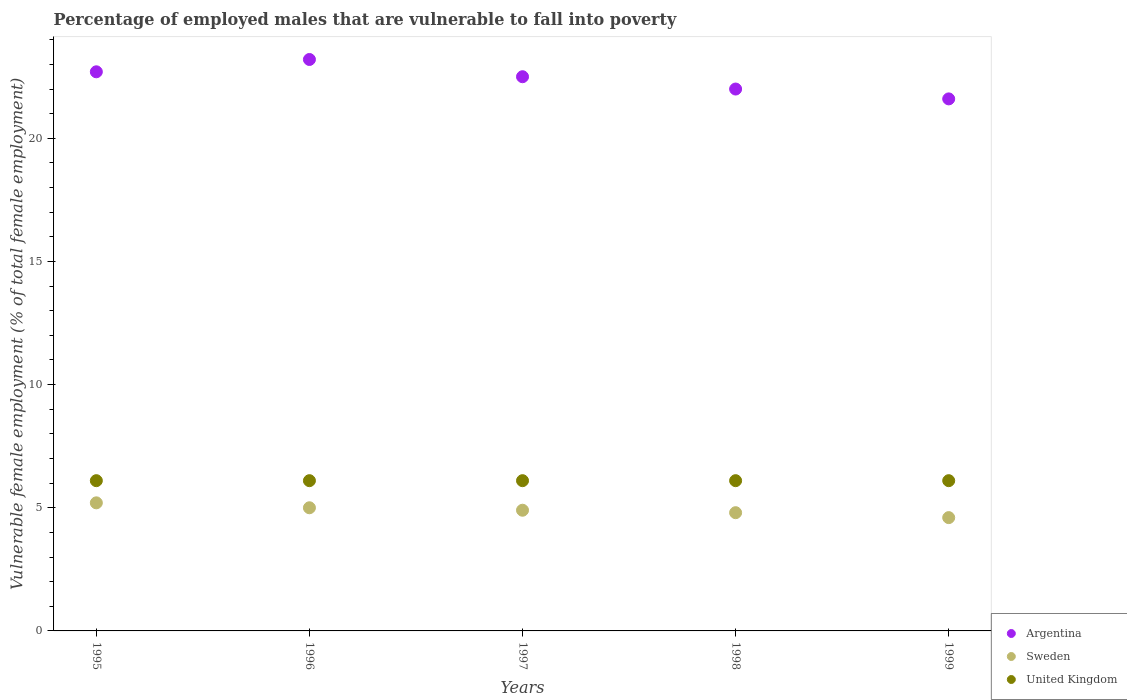How many different coloured dotlines are there?
Provide a short and direct response. 3. Is the number of dotlines equal to the number of legend labels?
Offer a very short reply. Yes. What is the percentage of employed males who are vulnerable to fall into poverty in United Kingdom in 1999?
Make the answer very short. 6.1. Across all years, what is the maximum percentage of employed males who are vulnerable to fall into poverty in Sweden?
Offer a very short reply. 5.2. Across all years, what is the minimum percentage of employed males who are vulnerable to fall into poverty in United Kingdom?
Your answer should be very brief. 6.1. In which year was the percentage of employed males who are vulnerable to fall into poverty in Sweden maximum?
Make the answer very short. 1995. What is the total percentage of employed males who are vulnerable to fall into poverty in United Kingdom in the graph?
Provide a short and direct response. 30.5. What is the difference between the percentage of employed males who are vulnerable to fall into poverty in Sweden in 1996 and that in 1997?
Give a very brief answer. 0.1. What is the difference between the percentage of employed males who are vulnerable to fall into poverty in United Kingdom in 1999 and the percentage of employed males who are vulnerable to fall into poverty in Sweden in 1996?
Offer a very short reply. 1.1. What is the average percentage of employed males who are vulnerable to fall into poverty in Sweden per year?
Your answer should be very brief. 4.9. In the year 1999, what is the difference between the percentage of employed males who are vulnerable to fall into poverty in Argentina and percentage of employed males who are vulnerable to fall into poverty in Sweden?
Your response must be concise. 17. In how many years, is the percentage of employed males who are vulnerable to fall into poverty in Sweden greater than 23 %?
Give a very brief answer. 0. Is the percentage of employed males who are vulnerable to fall into poverty in Sweden in 1998 less than that in 1999?
Your response must be concise. No. Is the difference between the percentage of employed males who are vulnerable to fall into poverty in Argentina in 1995 and 1997 greater than the difference between the percentage of employed males who are vulnerable to fall into poverty in Sweden in 1995 and 1997?
Your answer should be compact. No. What is the difference between the highest and the second highest percentage of employed males who are vulnerable to fall into poverty in Argentina?
Keep it short and to the point. 0.5. Does the percentage of employed males who are vulnerable to fall into poverty in Argentina monotonically increase over the years?
Your answer should be very brief. No. Is the percentage of employed males who are vulnerable to fall into poverty in Sweden strictly less than the percentage of employed males who are vulnerable to fall into poverty in United Kingdom over the years?
Your answer should be very brief. Yes. How many dotlines are there?
Offer a very short reply. 3. What is the difference between two consecutive major ticks on the Y-axis?
Make the answer very short. 5. Does the graph contain grids?
Provide a short and direct response. No. Where does the legend appear in the graph?
Offer a terse response. Bottom right. How are the legend labels stacked?
Provide a succinct answer. Vertical. What is the title of the graph?
Your answer should be compact. Percentage of employed males that are vulnerable to fall into poverty. What is the label or title of the Y-axis?
Offer a terse response. Vulnerable female employment (% of total female employment). What is the Vulnerable female employment (% of total female employment) of Argentina in 1995?
Offer a very short reply. 22.7. What is the Vulnerable female employment (% of total female employment) of Sweden in 1995?
Make the answer very short. 5.2. What is the Vulnerable female employment (% of total female employment) of United Kingdom in 1995?
Give a very brief answer. 6.1. What is the Vulnerable female employment (% of total female employment) of Argentina in 1996?
Keep it short and to the point. 23.2. What is the Vulnerable female employment (% of total female employment) of Sweden in 1996?
Make the answer very short. 5. What is the Vulnerable female employment (% of total female employment) in United Kingdom in 1996?
Offer a very short reply. 6.1. What is the Vulnerable female employment (% of total female employment) in Argentina in 1997?
Offer a terse response. 22.5. What is the Vulnerable female employment (% of total female employment) of Sweden in 1997?
Keep it short and to the point. 4.9. What is the Vulnerable female employment (% of total female employment) of United Kingdom in 1997?
Your answer should be compact. 6.1. What is the Vulnerable female employment (% of total female employment) of Argentina in 1998?
Give a very brief answer. 22. What is the Vulnerable female employment (% of total female employment) of Sweden in 1998?
Keep it short and to the point. 4.8. What is the Vulnerable female employment (% of total female employment) in United Kingdom in 1998?
Ensure brevity in your answer.  6.1. What is the Vulnerable female employment (% of total female employment) of Argentina in 1999?
Offer a terse response. 21.6. What is the Vulnerable female employment (% of total female employment) in Sweden in 1999?
Ensure brevity in your answer.  4.6. What is the Vulnerable female employment (% of total female employment) of United Kingdom in 1999?
Give a very brief answer. 6.1. Across all years, what is the maximum Vulnerable female employment (% of total female employment) in Argentina?
Offer a very short reply. 23.2. Across all years, what is the maximum Vulnerable female employment (% of total female employment) in Sweden?
Provide a short and direct response. 5.2. Across all years, what is the maximum Vulnerable female employment (% of total female employment) of United Kingdom?
Your response must be concise. 6.1. Across all years, what is the minimum Vulnerable female employment (% of total female employment) of Argentina?
Your answer should be compact. 21.6. Across all years, what is the minimum Vulnerable female employment (% of total female employment) in Sweden?
Give a very brief answer. 4.6. Across all years, what is the minimum Vulnerable female employment (% of total female employment) in United Kingdom?
Give a very brief answer. 6.1. What is the total Vulnerable female employment (% of total female employment) of Argentina in the graph?
Keep it short and to the point. 112. What is the total Vulnerable female employment (% of total female employment) in United Kingdom in the graph?
Offer a very short reply. 30.5. What is the difference between the Vulnerable female employment (% of total female employment) in Sweden in 1995 and that in 1997?
Your answer should be very brief. 0.3. What is the difference between the Vulnerable female employment (% of total female employment) of Sweden in 1995 and that in 1998?
Keep it short and to the point. 0.4. What is the difference between the Vulnerable female employment (% of total female employment) in United Kingdom in 1995 and that in 1998?
Give a very brief answer. 0. What is the difference between the Vulnerable female employment (% of total female employment) of Argentina in 1995 and that in 1999?
Your answer should be very brief. 1.1. What is the difference between the Vulnerable female employment (% of total female employment) in Sweden in 1995 and that in 1999?
Your answer should be compact. 0.6. What is the difference between the Vulnerable female employment (% of total female employment) in United Kingdom in 1996 and that in 1998?
Your response must be concise. 0. What is the difference between the Vulnerable female employment (% of total female employment) of Sweden in 1996 and that in 1999?
Your answer should be compact. 0.4. What is the difference between the Vulnerable female employment (% of total female employment) of Argentina in 1997 and that in 1998?
Offer a very short reply. 0.5. What is the difference between the Vulnerable female employment (% of total female employment) of United Kingdom in 1997 and that in 1998?
Provide a succinct answer. 0. What is the difference between the Vulnerable female employment (% of total female employment) in Argentina in 1997 and that in 1999?
Provide a short and direct response. 0.9. What is the difference between the Vulnerable female employment (% of total female employment) in United Kingdom in 1997 and that in 1999?
Your answer should be compact. 0. What is the difference between the Vulnerable female employment (% of total female employment) in Sweden in 1998 and that in 1999?
Your answer should be compact. 0.2. What is the difference between the Vulnerable female employment (% of total female employment) in Argentina in 1995 and the Vulnerable female employment (% of total female employment) in Sweden in 1996?
Offer a very short reply. 17.7. What is the difference between the Vulnerable female employment (% of total female employment) in Argentina in 1995 and the Vulnerable female employment (% of total female employment) in United Kingdom in 1996?
Ensure brevity in your answer.  16.6. What is the difference between the Vulnerable female employment (% of total female employment) of Sweden in 1995 and the Vulnerable female employment (% of total female employment) of United Kingdom in 1997?
Keep it short and to the point. -0.9. What is the difference between the Vulnerable female employment (% of total female employment) in Argentina in 1995 and the Vulnerable female employment (% of total female employment) in Sweden in 1998?
Your response must be concise. 17.9. What is the difference between the Vulnerable female employment (% of total female employment) in Sweden in 1995 and the Vulnerable female employment (% of total female employment) in United Kingdom in 1998?
Give a very brief answer. -0.9. What is the difference between the Vulnerable female employment (% of total female employment) of Argentina in 1995 and the Vulnerable female employment (% of total female employment) of Sweden in 1999?
Your response must be concise. 18.1. What is the difference between the Vulnerable female employment (% of total female employment) of Sweden in 1995 and the Vulnerable female employment (% of total female employment) of United Kingdom in 1999?
Your answer should be very brief. -0.9. What is the difference between the Vulnerable female employment (% of total female employment) of Argentina in 1996 and the Vulnerable female employment (% of total female employment) of Sweden in 1997?
Your response must be concise. 18.3. What is the difference between the Vulnerable female employment (% of total female employment) in Argentina in 1996 and the Vulnerable female employment (% of total female employment) in United Kingdom in 1997?
Your answer should be very brief. 17.1. What is the difference between the Vulnerable female employment (% of total female employment) in Sweden in 1996 and the Vulnerable female employment (% of total female employment) in United Kingdom in 1998?
Provide a short and direct response. -1.1. What is the difference between the Vulnerable female employment (% of total female employment) of Argentina in 1996 and the Vulnerable female employment (% of total female employment) of Sweden in 1999?
Offer a very short reply. 18.6. What is the difference between the Vulnerable female employment (% of total female employment) of Argentina in 1996 and the Vulnerable female employment (% of total female employment) of United Kingdom in 1999?
Give a very brief answer. 17.1. What is the difference between the Vulnerable female employment (% of total female employment) in Sweden in 1996 and the Vulnerable female employment (% of total female employment) in United Kingdom in 1999?
Your answer should be very brief. -1.1. What is the difference between the Vulnerable female employment (% of total female employment) of Argentina in 1997 and the Vulnerable female employment (% of total female employment) of Sweden in 1998?
Ensure brevity in your answer.  17.7. What is the difference between the Vulnerable female employment (% of total female employment) of Argentina in 1997 and the Vulnerable female employment (% of total female employment) of United Kingdom in 1998?
Make the answer very short. 16.4. What is the difference between the Vulnerable female employment (% of total female employment) in Sweden in 1997 and the Vulnerable female employment (% of total female employment) in United Kingdom in 1998?
Give a very brief answer. -1.2. What is the difference between the Vulnerable female employment (% of total female employment) in Argentina in 1998 and the Vulnerable female employment (% of total female employment) in Sweden in 1999?
Offer a very short reply. 17.4. What is the difference between the Vulnerable female employment (% of total female employment) in Argentina in 1998 and the Vulnerable female employment (% of total female employment) in United Kingdom in 1999?
Provide a succinct answer. 15.9. What is the average Vulnerable female employment (% of total female employment) of Argentina per year?
Provide a short and direct response. 22.4. What is the average Vulnerable female employment (% of total female employment) of Sweden per year?
Your answer should be compact. 4.9. In the year 1997, what is the difference between the Vulnerable female employment (% of total female employment) of Argentina and Vulnerable female employment (% of total female employment) of Sweden?
Offer a very short reply. 17.6. In the year 1997, what is the difference between the Vulnerable female employment (% of total female employment) of Argentina and Vulnerable female employment (% of total female employment) of United Kingdom?
Your answer should be compact. 16.4. In the year 1997, what is the difference between the Vulnerable female employment (% of total female employment) of Sweden and Vulnerable female employment (% of total female employment) of United Kingdom?
Make the answer very short. -1.2. In the year 1999, what is the difference between the Vulnerable female employment (% of total female employment) in Argentina and Vulnerable female employment (% of total female employment) in United Kingdom?
Provide a succinct answer. 15.5. What is the ratio of the Vulnerable female employment (% of total female employment) in Argentina in 1995 to that in 1996?
Offer a terse response. 0.98. What is the ratio of the Vulnerable female employment (% of total female employment) of United Kingdom in 1995 to that in 1996?
Your response must be concise. 1. What is the ratio of the Vulnerable female employment (% of total female employment) in Argentina in 1995 to that in 1997?
Make the answer very short. 1.01. What is the ratio of the Vulnerable female employment (% of total female employment) of Sweden in 1995 to that in 1997?
Give a very brief answer. 1.06. What is the ratio of the Vulnerable female employment (% of total female employment) in Argentina in 1995 to that in 1998?
Make the answer very short. 1.03. What is the ratio of the Vulnerable female employment (% of total female employment) of Sweden in 1995 to that in 1998?
Keep it short and to the point. 1.08. What is the ratio of the Vulnerable female employment (% of total female employment) of United Kingdom in 1995 to that in 1998?
Offer a terse response. 1. What is the ratio of the Vulnerable female employment (% of total female employment) of Argentina in 1995 to that in 1999?
Provide a succinct answer. 1.05. What is the ratio of the Vulnerable female employment (% of total female employment) of Sweden in 1995 to that in 1999?
Offer a terse response. 1.13. What is the ratio of the Vulnerable female employment (% of total female employment) of Argentina in 1996 to that in 1997?
Ensure brevity in your answer.  1.03. What is the ratio of the Vulnerable female employment (% of total female employment) in Sweden in 1996 to that in 1997?
Your response must be concise. 1.02. What is the ratio of the Vulnerable female employment (% of total female employment) of Argentina in 1996 to that in 1998?
Provide a short and direct response. 1.05. What is the ratio of the Vulnerable female employment (% of total female employment) in Sweden in 1996 to that in 1998?
Your response must be concise. 1.04. What is the ratio of the Vulnerable female employment (% of total female employment) of United Kingdom in 1996 to that in 1998?
Your answer should be compact. 1. What is the ratio of the Vulnerable female employment (% of total female employment) in Argentina in 1996 to that in 1999?
Provide a short and direct response. 1.07. What is the ratio of the Vulnerable female employment (% of total female employment) in Sweden in 1996 to that in 1999?
Your response must be concise. 1.09. What is the ratio of the Vulnerable female employment (% of total female employment) in Argentina in 1997 to that in 1998?
Provide a short and direct response. 1.02. What is the ratio of the Vulnerable female employment (% of total female employment) in Sweden in 1997 to that in 1998?
Your answer should be very brief. 1.02. What is the ratio of the Vulnerable female employment (% of total female employment) in United Kingdom in 1997 to that in 1998?
Provide a short and direct response. 1. What is the ratio of the Vulnerable female employment (% of total female employment) of Argentina in 1997 to that in 1999?
Make the answer very short. 1.04. What is the ratio of the Vulnerable female employment (% of total female employment) of Sweden in 1997 to that in 1999?
Your answer should be very brief. 1.07. What is the ratio of the Vulnerable female employment (% of total female employment) in United Kingdom in 1997 to that in 1999?
Give a very brief answer. 1. What is the ratio of the Vulnerable female employment (% of total female employment) of Argentina in 1998 to that in 1999?
Make the answer very short. 1.02. What is the ratio of the Vulnerable female employment (% of total female employment) in Sweden in 1998 to that in 1999?
Ensure brevity in your answer.  1.04. What is the ratio of the Vulnerable female employment (% of total female employment) in United Kingdom in 1998 to that in 1999?
Give a very brief answer. 1. What is the difference between the highest and the lowest Vulnerable female employment (% of total female employment) of Argentina?
Your answer should be very brief. 1.6. What is the difference between the highest and the lowest Vulnerable female employment (% of total female employment) in Sweden?
Keep it short and to the point. 0.6. 